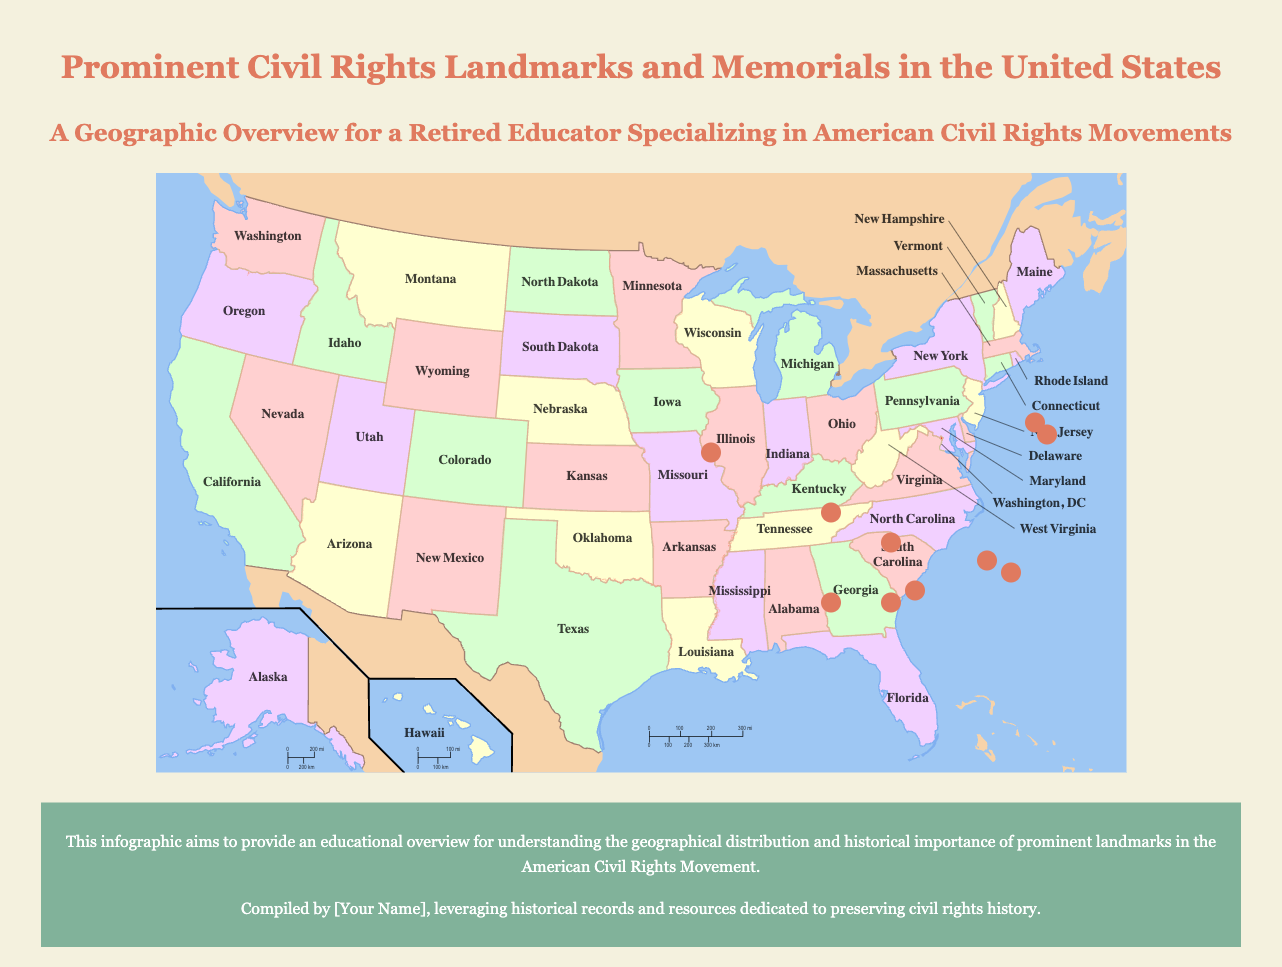What landmark is located in Selma, Alabama? The document lists the Edmund Pettus Bridge as located in Selma, Alabama.
Answer: Edmund Pettus Bridge Which historical site is associated with Dr. Martin Luther King Jr. in Atlanta, Georgia? The infographic mentions the Martin Luther King Jr. National Historical Park as associated with Dr. King in Atlanta, Georgia.
Answer: Martin Luther King Jr. National Historical Park What significant event occurred at the 16th Street Baptist Church? The document states that the 1963 bombing that killed four African-American girls occurred at the 16th Street Baptist Church.
Answer: 1963 bombing Where is the National Civil Rights Museum located? The National Civil Rights Museum is located in Memphis, Tennessee according to the infographic.
Answer: Memphis, Tennessee What was the significance of the Brown v. Board of Education National Historic Site? The document states it commemorates the 1954 Supreme Court decision declaring racial segregation in public schools unconstitutional.
Answer: Landmark 1954 decision Which landmark symbolizes the fight for equality and justice as the site of a famous speech? The Lincoln Memorial is indicated as the site of Dr. Martin Luther King Jr.'s 'I Have a Dream' speech.
Answer: Lincoln Memorial What do the John and Lugenia Burns Hope contribute to in history? The document describes that John and Lugenia Burns Hope contributed to the advancement of African-American education and civic life.
Answer: Education and civic life What notable action took place at Little Rock Central High School in 1957? The infographic details that the desegregation crisis involving the 'Little Rock Nine' took place at Little Rock Central High School in 1957.
Answer: Desegregation crisis What type of content does The National Museum of African American History and Culture focus on? The museum focuses on documenting African American life, history, and culture from slavery to the present.
Answer: African American life and history 